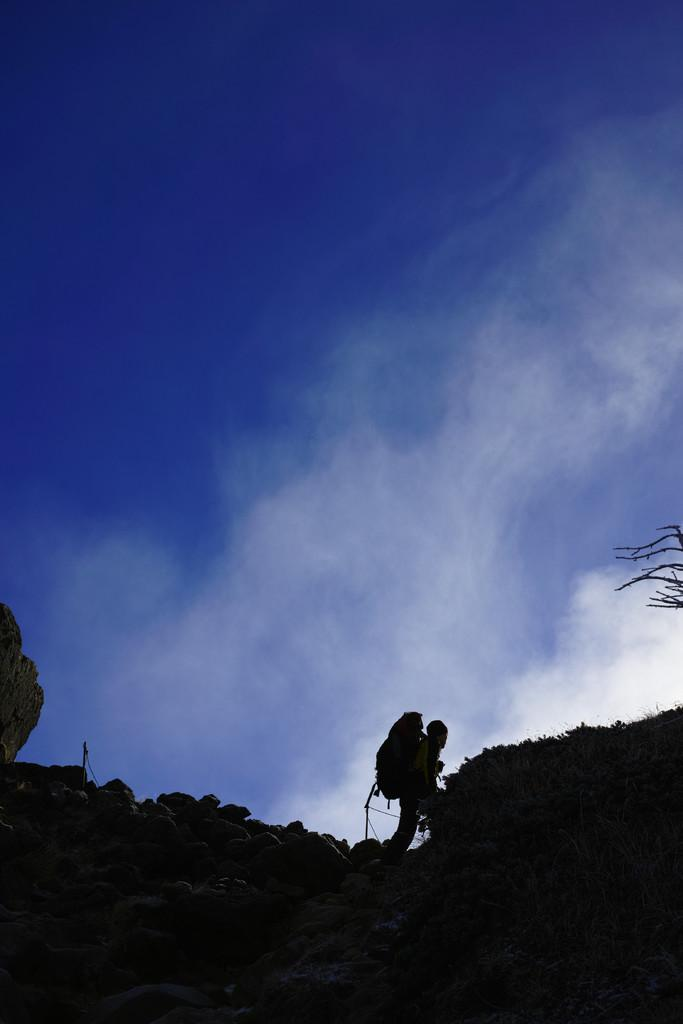What is the main subject of the image? There is a person standing in the image. What is the person wearing on their back? The person is wearing a backpack. What can be seen at the top of the image? The sky is visible at the top of the image. What type of stone is being used to measure the minute in the image? There is no stone or measurement of time present in the image. What flag is being displayed in the image? There is no flag present in the image. 